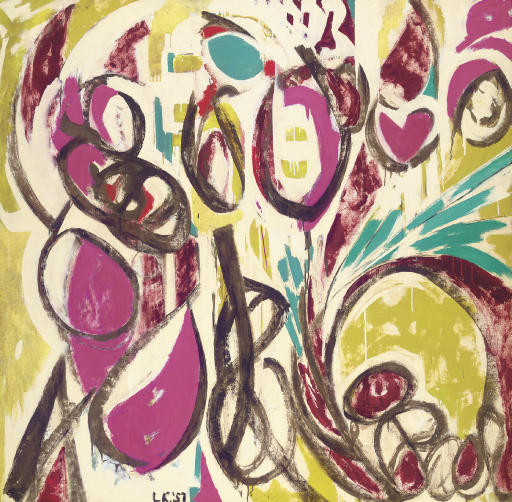Explain the visual content of the image in great detail. The image is a striking example of abstract expressionism, notable for its explosive use of colors and organic forms. Dominant colors like hot pink, mustard yellow, and pale green paint the canvas in a lively and chaotic array, suggesting freedom and spontaneity. The style mirrors that of street art with its bold, graffiti-like brushstrokes and diverse textures, adding richness and dynamic energy. The composition includes interconnected loops, swirls, and circular motifs that could symbolize continuity or connectedness. These elements, complemented by random splatters, create visual movement that might evoke different emotions in viewers. The artist, signed as 'Léon' on the bottom left, adds a personalized essence to the artwork, inviting viewers to interact deeply with the visual narrative. 